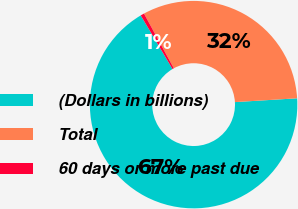Convert chart. <chart><loc_0><loc_0><loc_500><loc_500><pie_chart><fcel>(Dollars in billions)<fcel>Total<fcel>60 days or more past due<nl><fcel>67.46%<fcel>31.97%<fcel>0.57%<nl></chart> 